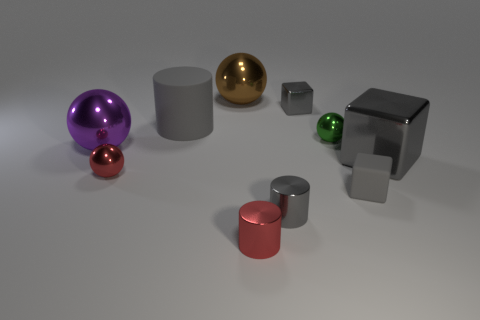Does the tiny shiny block have the same color as the big cylinder? Yes, the tiny shiny block shares the same hue as the big cylinder, both exhibiting a silver tone, reflecting the environment's light beautifully. 